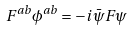<formula> <loc_0><loc_0><loc_500><loc_500>F ^ { a b } \phi ^ { a b } = - i \bar { \psi } F \psi</formula> 